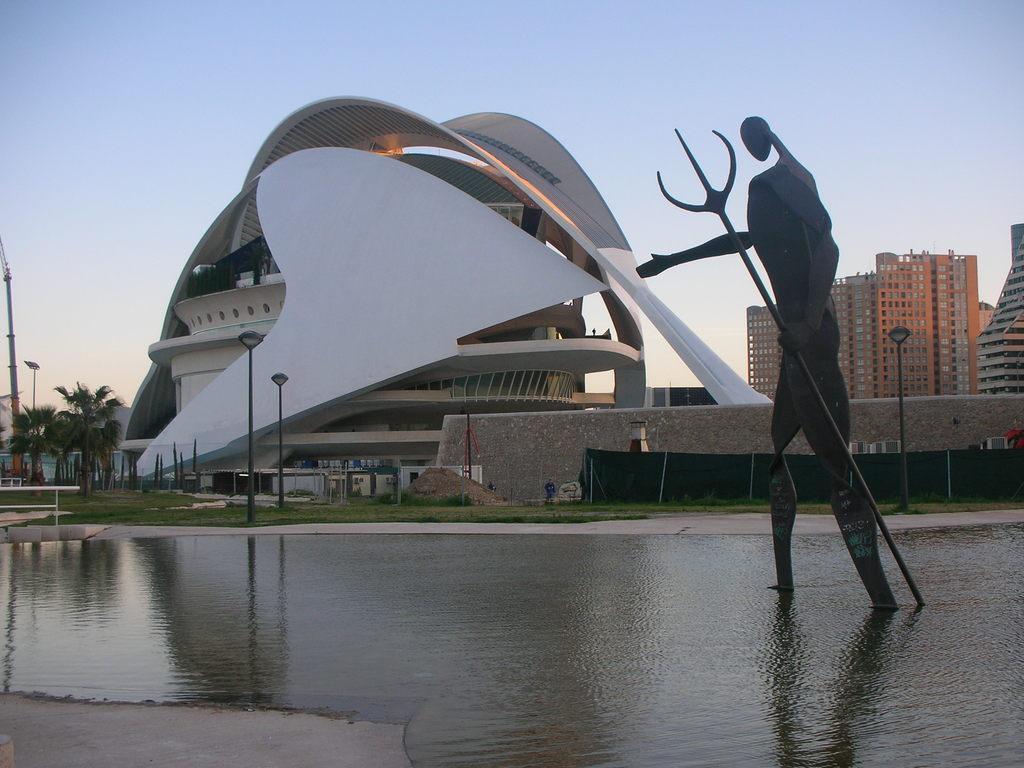Please provide a concise description of this image. On the right side of the image there is a metal sculpture of a person holding some object. In front of the image there is water. There are light poles, buildings, trees, banners, poles and a few other objects. There are people. At the bottom of the image there is grass on the surface. At the top of the image there is sky. 